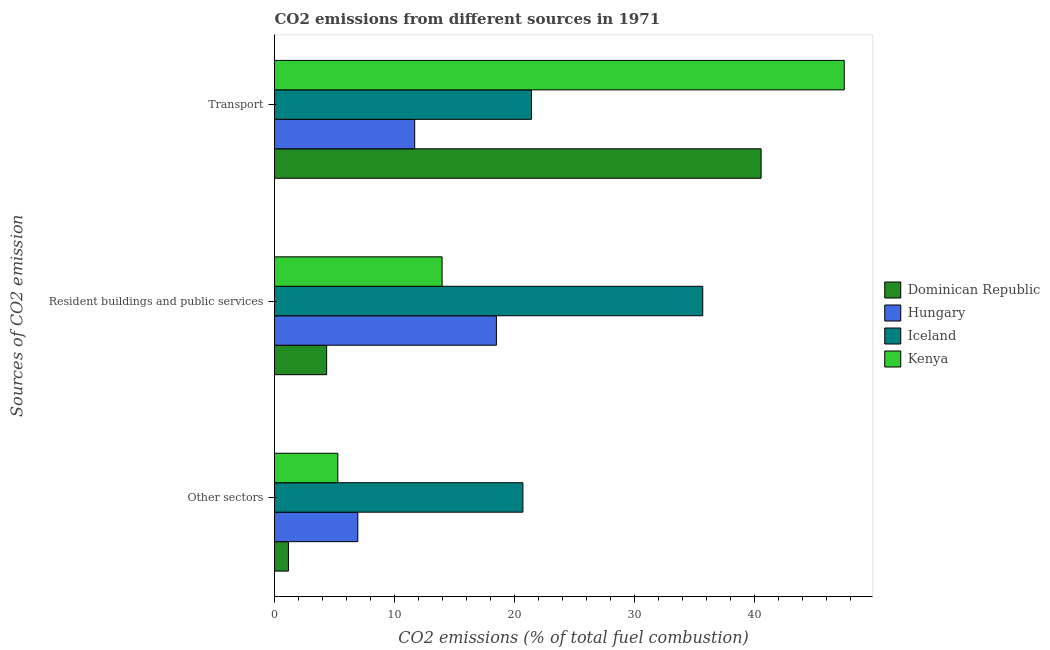How many different coloured bars are there?
Provide a short and direct response. 4. How many groups of bars are there?
Provide a succinct answer. 3. Are the number of bars per tick equal to the number of legend labels?
Provide a succinct answer. Yes. How many bars are there on the 3rd tick from the top?
Offer a very short reply. 4. What is the label of the 3rd group of bars from the top?
Your response must be concise. Other sectors. What is the percentage of co2 emissions from other sectors in Iceland?
Offer a terse response. 20.71. Across all countries, what is the maximum percentage of co2 emissions from resident buildings and public services?
Provide a succinct answer. 35.71. Across all countries, what is the minimum percentage of co2 emissions from transport?
Provide a short and direct response. 11.69. In which country was the percentage of co2 emissions from transport maximum?
Keep it short and to the point. Kenya. In which country was the percentage of co2 emissions from transport minimum?
Provide a succinct answer. Hungary. What is the total percentage of co2 emissions from other sectors in the graph?
Ensure brevity in your answer.  34.1. What is the difference between the percentage of co2 emissions from resident buildings and public services in Iceland and that in Dominican Republic?
Your answer should be compact. 31.37. What is the difference between the percentage of co2 emissions from transport in Hungary and the percentage of co2 emissions from resident buildings and public services in Dominican Republic?
Give a very brief answer. 7.34. What is the average percentage of co2 emissions from resident buildings and public services per country?
Offer a terse response. 18.14. What is the difference between the percentage of co2 emissions from other sectors and percentage of co2 emissions from resident buildings and public services in Dominican Republic?
Offer a very short reply. -3.19. What is the ratio of the percentage of co2 emissions from transport in Hungary to that in Iceland?
Offer a terse response. 0.55. Is the percentage of co2 emissions from other sectors in Iceland less than that in Kenya?
Provide a succinct answer. No. What is the difference between the highest and the second highest percentage of co2 emissions from other sectors?
Give a very brief answer. 13.77. What is the difference between the highest and the lowest percentage of co2 emissions from other sectors?
Ensure brevity in your answer.  19.55. Is the sum of the percentage of co2 emissions from transport in Iceland and Kenya greater than the maximum percentage of co2 emissions from resident buildings and public services across all countries?
Your answer should be very brief. Yes. What does the 4th bar from the top in Resident buildings and public services represents?
Provide a short and direct response. Dominican Republic. What does the 3rd bar from the bottom in Other sectors represents?
Give a very brief answer. Iceland. Are all the bars in the graph horizontal?
Your response must be concise. Yes. How many countries are there in the graph?
Provide a short and direct response. 4. What is the difference between two consecutive major ticks on the X-axis?
Your answer should be very brief. 10. Are the values on the major ticks of X-axis written in scientific E-notation?
Offer a very short reply. No. Does the graph contain grids?
Your response must be concise. No. Where does the legend appear in the graph?
Give a very brief answer. Center right. How many legend labels are there?
Provide a succinct answer. 4. What is the title of the graph?
Provide a short and direct response. CO2 emissions from different sources in 1971. What is the label or title of the X-axis?
Your answer should be very brief. CO2 emissions (% of total fuel combustion). What is the label or title of the Y-axis?
Give a very brief answer. Sources of CO2 emission. What is the CO2 emissions (% of total fuel combustion) of Dominican Republic in Other sectors?
Your answer should be compact. 1.16. What is the CO2 emissions (% of total fuel combustion) of Hungary in Other sectors?
Make the answer very short. 6.95. What is the CO2 emissions (% of total fuel combustion) in Iceland in Other sectors?
Give a very brief answer. 20.71. What is the CO2 emissions (% of total fuel combustion) of Kenya in Other sectors?
Make the answer very short. 5.28. What is the CO2 emissions (% of total fuel combustion) in Dominican Republic in Resident buildings and public services?
Your response must be concise. 4.35. What is the CO2 emissions (% of total fuel combustion) of Hungary in Resident buildings and public services?
Keep it short and to the point. 18.5. What is the CO2 emissions (% of total fuel combustion) in Iceland in Resident buildings and public services?
Your answer should be compact. 35.71. What is the CO2 emissions (% of total fuel combustion) of Kenya in Resident buildings and public services?
Make the answer very short. 13.98. What is the CO2 emissions (% of total fuel combustion) of Dominican Republic in Transport?
Provide a short and direct response. 40.58. What is the CO2 emissions (% of total fuel combustion) in Hungary in Transport?
Offer a terse response. 11.69. What is the CO2 emissions (% of total fuel combustion) in Iceland in Transport?
Give a very brief answer. 21.43. What is the CO2 emissions (% of total fuel combustion) of Kenya in Transport?
Your answer should be very brief. 47.52. Across all Sources of CO2 emission, what is the maximum CO2 emissions (% of total fuel combustion) in Dominican Republic?
Make the answer very short. 40.58. Across all Sources of CO2 emission, what is the maximum CO2 emissions (% of total fuel combustion) in Hungary?
Your response must be concise. 18.5. Across all Sources of CO2 emission, what is the maximum CO2 emissions (% of total fuel combustion) of Iceland?
Provide a short and direct response. 35.71. Across all Sources of CO2 emission, what is the maximum CO2 emissions (% of total fuel combustion) of Kenya?
Your response must be concise. 47.52. Across all Sources of CO2 emission, what is the minimum CO2 emissions (% of total fuel combustion) in Dominican Republic?
Offer a terse response. 1.16. Across all Sources of CO2 emission, what is the minimum CO2 emissions (% of total fuel combustion) of Hungary?
Provide a short and direct response. 6.95. Across all Sources of CO2 emission, what is the minimum CO2 emissions (% of total fuel combustion) of Iceland?
Provide a succinct answer. 20.71. Across all Sources of CO2 emission, what is the minimum CO2 emissions (% of total fuel combustion) of Kenya?
Keep it short and to the point. 5.28. What is the total CO2 emissions (% of total fuel combustion) in Dominican Republic in the graph?
Keep it short and to the point. 46.09. What is the total CO2 emissions (% of total fuel combustion) of Hungary in the graph?
Provide a short and direct response. 37.14. What is the total CO2 emissions (% of total fuel combustion) in Iceland in the graph?
Provide a short and direct response. 77.86. What is the total CO2 emissions (% of total fuel combustion) in Kenya in the graph?
Provide a succinct answer. 66.77. What is the difference between the CO2 emissions (% of total fuel combustion) in Dominican Republic in Other sectors and that in Resident buildings and public services?
Give a very brief answer. -3.19. What is the difference between the CO2 emissions (% of total fuel combustion) of Hungary in Other sectors and that in Resident buildings and public services?
Provide a succinct answer. -11.56. What is the difference between the CO2 emissions (% of total fuel combustion) of Iceland in Other sectors and that in Resident buildings and public services?
Give a very brief answer. -15. What is the difference between the CO2 emissions (% of total fuel combustion) of Kenya in Other sectors and that in Resident buildings and public services?
Provide a succinct answer. -8.7. What is the difference between the CO2 emissions (% of total fuel combustion) of Dominican Republic in Other sectors and that in Transport?
Give a very brief answer. -39.42. What is the difference between the CO2 emissions (% of total fuel combustion) of Hungary in Other sectors and that in Transport?
Provide a succinct answer. -4.74. What is the difference between the CO2 emissions (% of total fuel combustion) of Iceland in Other sectors and that in Transport?
Make the answer very short. -0.71. What is the difference between the CO2 emissions (% of total fuel combustion) in Kenya in Other sectors and that in Transport?
Your response must be concise. -42.24. What is the difference between the CO2 emissions (% of total fuel combustion) of Dominican Republic in Resident buildings and public services and that in Transport?
Make the answer very short. -36.23. What is the difference between the CO2 emissions (% of total fuel combustion) in Hungary in Resident buildings and public services and that in Transport?
Your answer should be compact. 6.81. What is the difference between the CO2 emissions (% of total fuel combustion) of Iceland in Resident buildings and public services and that in Transport?
Your response must be concise. 14.29. What is the difference between the CO2 emissions (% of total fuel combustion) in Kenya in Resident buildings and public services and that in Transport?
Make the answer very short. -33.54. What is the difference between the CO2 emissions (% of total fuel combustion) of Dominican Republic in Other sectors and the CO2 emissions (% of total fuel combustion) of Hungary in Resident buildings and public services?
Offer a very short reply. -17.34. What is the difference between the CO2 emissions (% of total fuel combustion) of Dominican Republic in Other sectors and the CO2 emissions (% of total fuel combustion) of Iceland in Resident buildings and public services?
Make the answer very short. -34.55. What is the difference between the CO2 emissions (% of total fuel combustion) of Dominican Republic in Other sectors and the CO2 emissions (% of total fuel combustion) of Kenya in Resident buildings and public services?
Give a very brief answer. -12.82. What is the difference between the CO2 emissions (% of total fuel combustion) in Hungary in Other sectors and the CO2 emissions (% of total fuel combustion) in Iceland in Resident buildings and public services?
Your answer should be very brief. -28.77. What is the difference between the CO2 emissions (% of total fuel combustion) in Hungary in Other sectors and the CO2 emissions (% of total fuel combustion) in Kenya in Resident buildings and public services?
Ensure brevity in your answer.  -7.03. What is the difference between the CO2 emissions (% of total fuel combustion) of Iceland in Other sectors and the CO2 emissions (% of total fuel combustion) of Kenya in Resident buildings and public services?
Your response must be concise. 6.74. What is the difference between the CO2 emissions (% of total fuel combustion) of Dominican Republic in Other sectors and the CO2 emissions (% of total fuel combustion) of Hungary in Transport?
Offer a terse response. -10.53. What is the difference between the CO2 emissions (% of total fuel combustion) in Dominican Republic in Other sectors and the CO2 emissions (% of total fuel combustion) in Iceland in Transport?
Keep it short and to the point. -20.27. What is the difference between the CO2 emissions (% of total fuel combustion) in Dominican Republic in Other sectors and the CO2 emissions (% of total fuel combustion) in Kenya in Transport?
Provide a succinct answer. -46.36. What is the difference between the CO2 emissions (% of total fuel combustion) in Hungary in Other sectors and the CO2 emissions (% of total fuel combustion) in Iceland in Transport?
Your answer should be compact. -14.48. What is the difference between the CO2 emissions (% of total fuel combustion) of Hungary in Other sectors and the CO2 emissions (% of total fuel combustion) of Kenya in Transport?
Your answer should be very brief. -40.57. What is the difference between the CO2 emissions (% of total fuel combustion) of Iceland in Other sectors and the CO2 emissions (% of total fuel combustion) of Kenya in Transport?
Give a very brief answer. -26.8. What is the difference between the CO2 emissions (% of total fuel combustion) in Dominican Republic in Resident buildings and public services and the CO2 emissions (% of total fuel combustion) in Hungary in Transport?
Your response must be concise. -7.34. What is the difference between the CO2 emissions (% of total fuel combustion) of Dominican Republic in Resident buildings and public services and the CO2 emissions (% of total fuel combustion) of Iceland in Transport?
Your answer should be very brief. -17.08. What is the difference between the CO2 emissions (% of total fuel combustion) of Dominican Republic in Resident buildings and public services and the CO2 emissions (% of total fuel combustion) of Kenya in Transport?
Give a very brief answer. -43.17. What is the difference between the CO2 emissions (% of total fuel combustion) in Hungary in Resident buildings and public services and the CO2 emissions (% of total fuel combustion) in Iceland in Transport?
Ensure brevity in your answer.  -2.92. What is the difference between the CO2 emissions (% of total fuel combustion) in Hungary in Resident buildings and public services and the CO2 emissions (% of total fuel combustion) in Kenya in Transport?
Provide a succinct answer. -29.01. What is the difference between the CO2 emissions (% of total fuel combustion) in Iceland in Resident buildings and public services and the CO2 emissions (% of total fuel combustion) in Kenya in Transport?
Offer a very short reply. -11.8. What is the average CO2 emissions (% of total fuel combustion) of Dominican Republic per Sources of CO2 emission?
Make the answer very short. 15.36. What is the average CO2 emissions (% of total fuel combustion) of Hungary per Sources of CO2 emission?
Provide a short and direct response. 12.38. What is the average CO2 emissions (% of total fuel combustion) in Iceland per Sources of CO2 emission?
Your answer should be compact. 25.95. What is the average CO2 emissions (% of total fuel combustion) in Kenya per Sources of CO2 emission?
Provide a short and direct response. 22.26. What is the difference between the CO2 emissions (% of total fuel combustion) of Dominican Republic and CO2 emissions (% of total fuel combustion) of Hungary in Other sectors?
Your response must be concise. -5.79. What is the difference between the CO2 emissions (% of total fuel combustion) of Dominican Republic and CO2 emissions (% of total fuel combustion) of Iceland in Other sectors?
Your answer should be very brief. -19.55. What is the difference between the CO2 emissions (% of total fuel combustion) in Dominican Republic and CO2 emissions (% of total fuel combustion) in Kenya in Other sectors?
Provide a succinct answer. -4.12. What is the difference between the CO2 emissions (% of total fuel combustion) of Hungary and CO2 emissions (% of total fuel combustion) of Iceland in Other sectors?
Make the answer very short. -13.77. What is the difference between the CO2 emissions (% of total fuel combustion) in Hungary and CO2 emissions (% of total fuel combustion) in Kenya in Other sectors?
Give a very brief answer. 1.67. What is the difference between the CO2 emissions (% of total fuel combustion) of Iceland and CO2 emissions (% of total fuel combustion) of Kenya in Other sectors?
Provide a succinct answer. 15.43. What is the difference between the CO2 emissions (% of total fuel combustion) of Dominican Republic and CO2 emissions (% of total fuel combustion) of Hungary in Resident buildings and public services?
Keep it short and to the point. -14.16. What is the difference between the CO2 emissions (% of total fuel combustion) of Dominican Republic and CO2 emissions (% of total fuel combustion) of Iceland in Resident buildings and public services?
Make the answer very short. -31.37. What is the difference between the CO2 emissions (% of total fuel combustion) of Dominican Republic and CO2 emissions (% of total fuel combustion) of Kenya in Resident buildings and public services?
Offer a very short reply. -9.63. What is the difference between the CO2 emissions (% of total fuel combustion) in Hungary and CO2 emissions (% of total fuel combustion) in Iceland in Resident buildings and public services?
Offer a very short reply. -17.21. What is the difference between the CO2 emissions (% of total fuel combustion) of Hungary and CO2 emissions (% of total fuel combustion) of Kenya in Resident buildings and public services?
Your answer should be very brief. 4.53. What is the difference between the CO2 emissions (% of total fuel combustion) of Iceland and CO2 emissions (% of total fuel combustion) of Kenya in Resident buildings and public services?
Ensure brevity in your answer.  21.74. What is the difference between the CO2 emissions (% of total fuel combustion) of Dominican Republic and CO2 emissions (% of total fuel combustion) of Hungary in Transport?
Your response must be concise. 28.89. What is the difference between the CO2 emissions (% of total fuel combustion) of Dominican Republic and CO2 emissions (% of total fuel combustion) of Iceland in Transport?
Provide a succinct answer. 19.15. What is the difference between the CO2 emissions (% of total fuel combustion) of Dominican Republic and CO2 emissions (% of total fuel combustion) of Kenya in Transport?
Your answer should be compact. -6.94. What is the difference between the CO2 emissions (% of total fuel combustion) in Hungary and CO2 emissions (% of total fuel combustion) in Iceland in Transport?
Make the answer very short. -9.74. What is the difference between the CO2 emissions (% of total fuel combustion) in Hungary and CO2 emissions (% of total fuel combustion) in Kenya in Transport?
Make the answer very short. -35.83. What is the difference between the CO2 emissions (% of total fuel combustion) in Iceland and CO2 emissions (% of total fuel combustion) in Kenya in Transport?
Offer a very short reply. -26.09. What is the ratio of the CO2 emissions (% of total fuel combustion) in Dominican Republic in Other sectors to that in Resident buildings and public services?
Provide a succinct answer. 0.27. What is the ratio of the CO2 emissions (% of total fuel combustion) of Hungary in Other sectors to that in Resident buildings and public services?
Make the answer very short. 0.38. What is the ratio of the CO2 emissions (% of total fuel combustion) of Iceland in Other sectors to that in Resident buildings and public services?
Keep it short and to the point. 0.58. What is the ratio of the CO2 emissions (% of total fuel combustion) of Kenya in Other sectors to that in Resident buildings and public services?
Give a very brief answer. 0.38. What is the ratio of the CO2 emissions (% of total fuel combustion) in Dominican Republic in Other sectors to that in Transport?
Provide a short and direct response. 0.03. What is the ratio of the CO2 emissions (% of total fuel combustion) of Hungary in Other sectors to that in Transport?
Your response must be concise. 0.59. What is the ratio of the CO2 emissions (% of total fuel combustion) of Iceland in Other sectors to that in Transport?
Offer a very short reply. 0.97. What is the ratio of the CO2 emissions (% of total fuel combustion) in Kenya in Other sectors to that in Transport?
Provide a succinct answer. 0.11. What is the ratio of the CO2 emissions (% of total fuel combustion) of Dominican Republic in Resident buildings and public services to that in Transport?
Your response must be concise. 0.11. What is the ratio of the CO2 emissions (% of total fuel combustion) of Hungary in Resident buildings and public services to that in Transport?
Ensure brevity in your answer.  1.58. What is the ratio of the CO2 emissions (% of total fuel combustion) of Iceland in Resident buildings and public services to that in Transport?
Ensure brevity in your answer.  1.67. What is the ratio of the CO2 emissions (% of total fuel combustion) in Kenya in Resident buildings and public services to that in Transport?
Offer a terse response. 0.29. What is the difference between the highest and the second highest CO2 emissions (% of total fuel combustion) of Dominican Republic?
Your answer should be very brief. 36.23. What is the difference between the highest and the second highest CO2 emissions (% of total fuel combustion) in Hungary?
Offer a terse response. 6.81. What is the difference between the highest and the second highest CO2 emissions (% of total fuel combustion) of Iceland?
Offer a very short reply. 14.29. What is the difference between the highest and the second highest CO2 emissions (% of total fuel combustion) of Kenya?
Provide a short and direct response. 33.54. What is the difference between the highest and the lowest CO2 emissions (% of total fuel combustion) of Dominican Republic?
Give a very brief answer. 39.42. What is the difference between the highest and the lowest CO2 emissions (% of total fuel combustion) of Hungary?
Give a very brief answer. 11.56. What is the difference between the highest and the lowest CO2 emissions (% of total fuel combustion) of Iceland?
Provide a short and direct response. 15. What is the difference between the highest and the lowest CO2 emissions (% of total fuel combustion) in Kenya?
Keep it short and to the point. 42.24. 